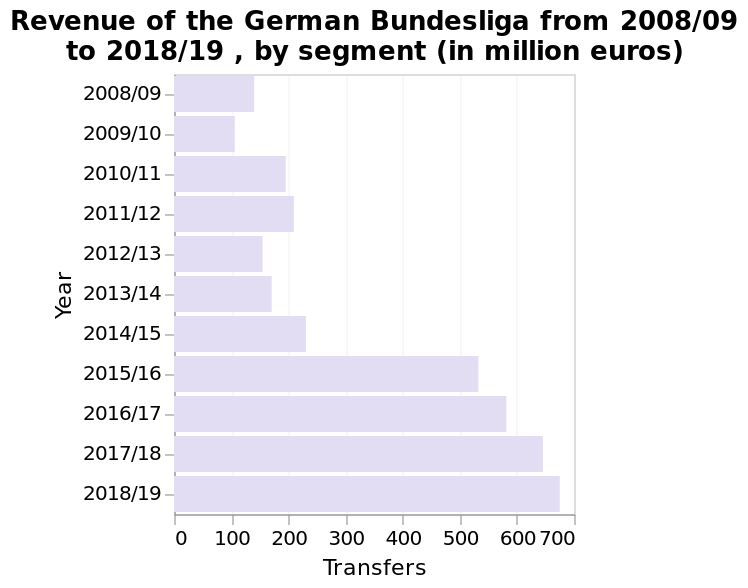<image>
please summary the statistics and relations of the chart Revenue in the German Bundesliga rose sharply between 2014-15 (around 220 million transfers) and 2015-16 (around 520 million transfers) and has continued to increase year on year since then to around 680 million in 2018-19. How much did the revenue increase in the German Bundesliga from 2014-15 to 2015-16? The revenue in the German Bundesliga increased from around 220 million transfers in 2014-15 to around 520 million transfers in 2015-16. What is the title of the bar diagram?  The title of the bar diagram is "Revenue of the German Bundesliga from 2008/09 to 2018/19, by segment (in million euros)." What is the trend in revenue growth in the German Bundesliga? The revenue in the German Bundesliga has been consistently increasing since 2014-15, with a sharp rise from 2014-15 to 2015-16, and continued growth year on year since then. What was the revenue in the German Bundesliga in 2014-15? The revenue in the German Bundesliga in 2014-15 was around 220 million transfers. Has the revenue in the German Bundesliga been consistently decreasing since 2014-15, with a sharp decline from 2014-15 to 2015-16, and continued decline year on year since then? No.The revenue in the German Bundesliga has been consistently increasing since 2014-15, with a sharp rise from 2014-15 to 2015-16, and continued growth year on year since then. 